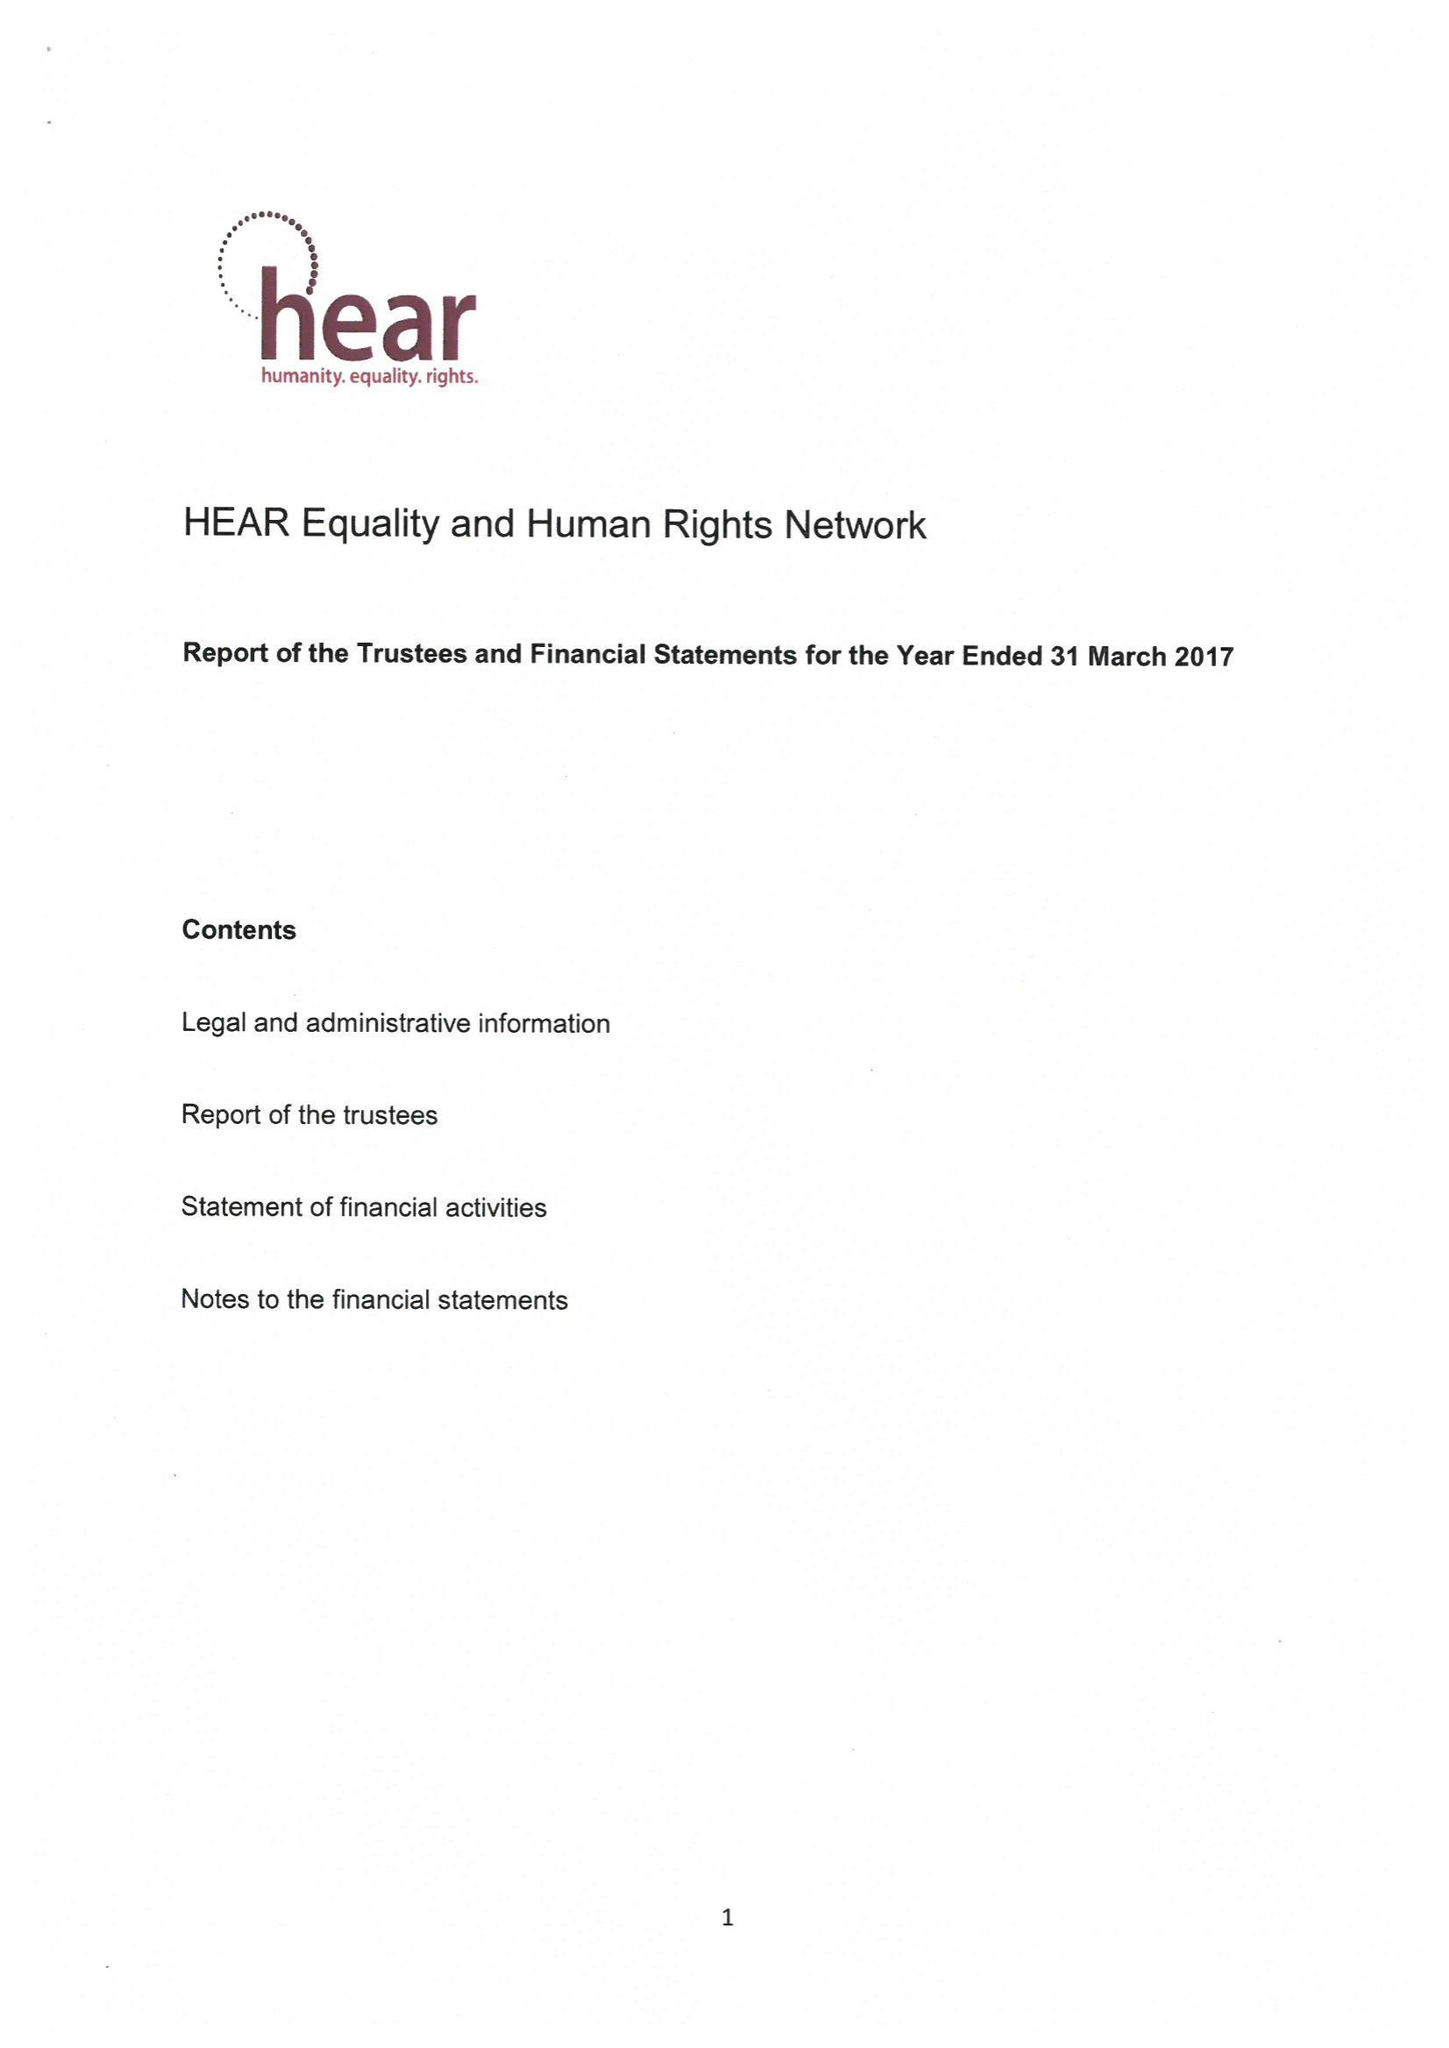What is the value for the address__street_line?
Answer the question using a single word or phrase. 200A PENTONVILLE ROAD 